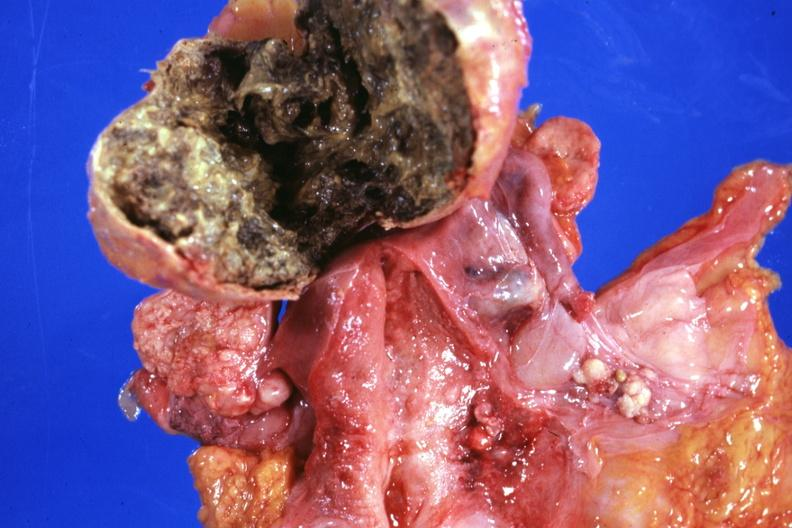what is present?
Answer the question using a single word or phrase. Female reproductive 